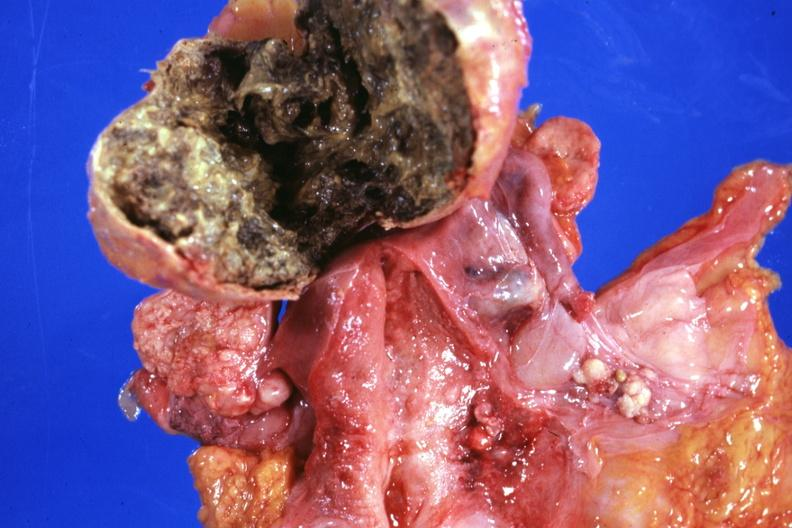what is present?
Answer the question using a single word or phrase. Female reproductive 